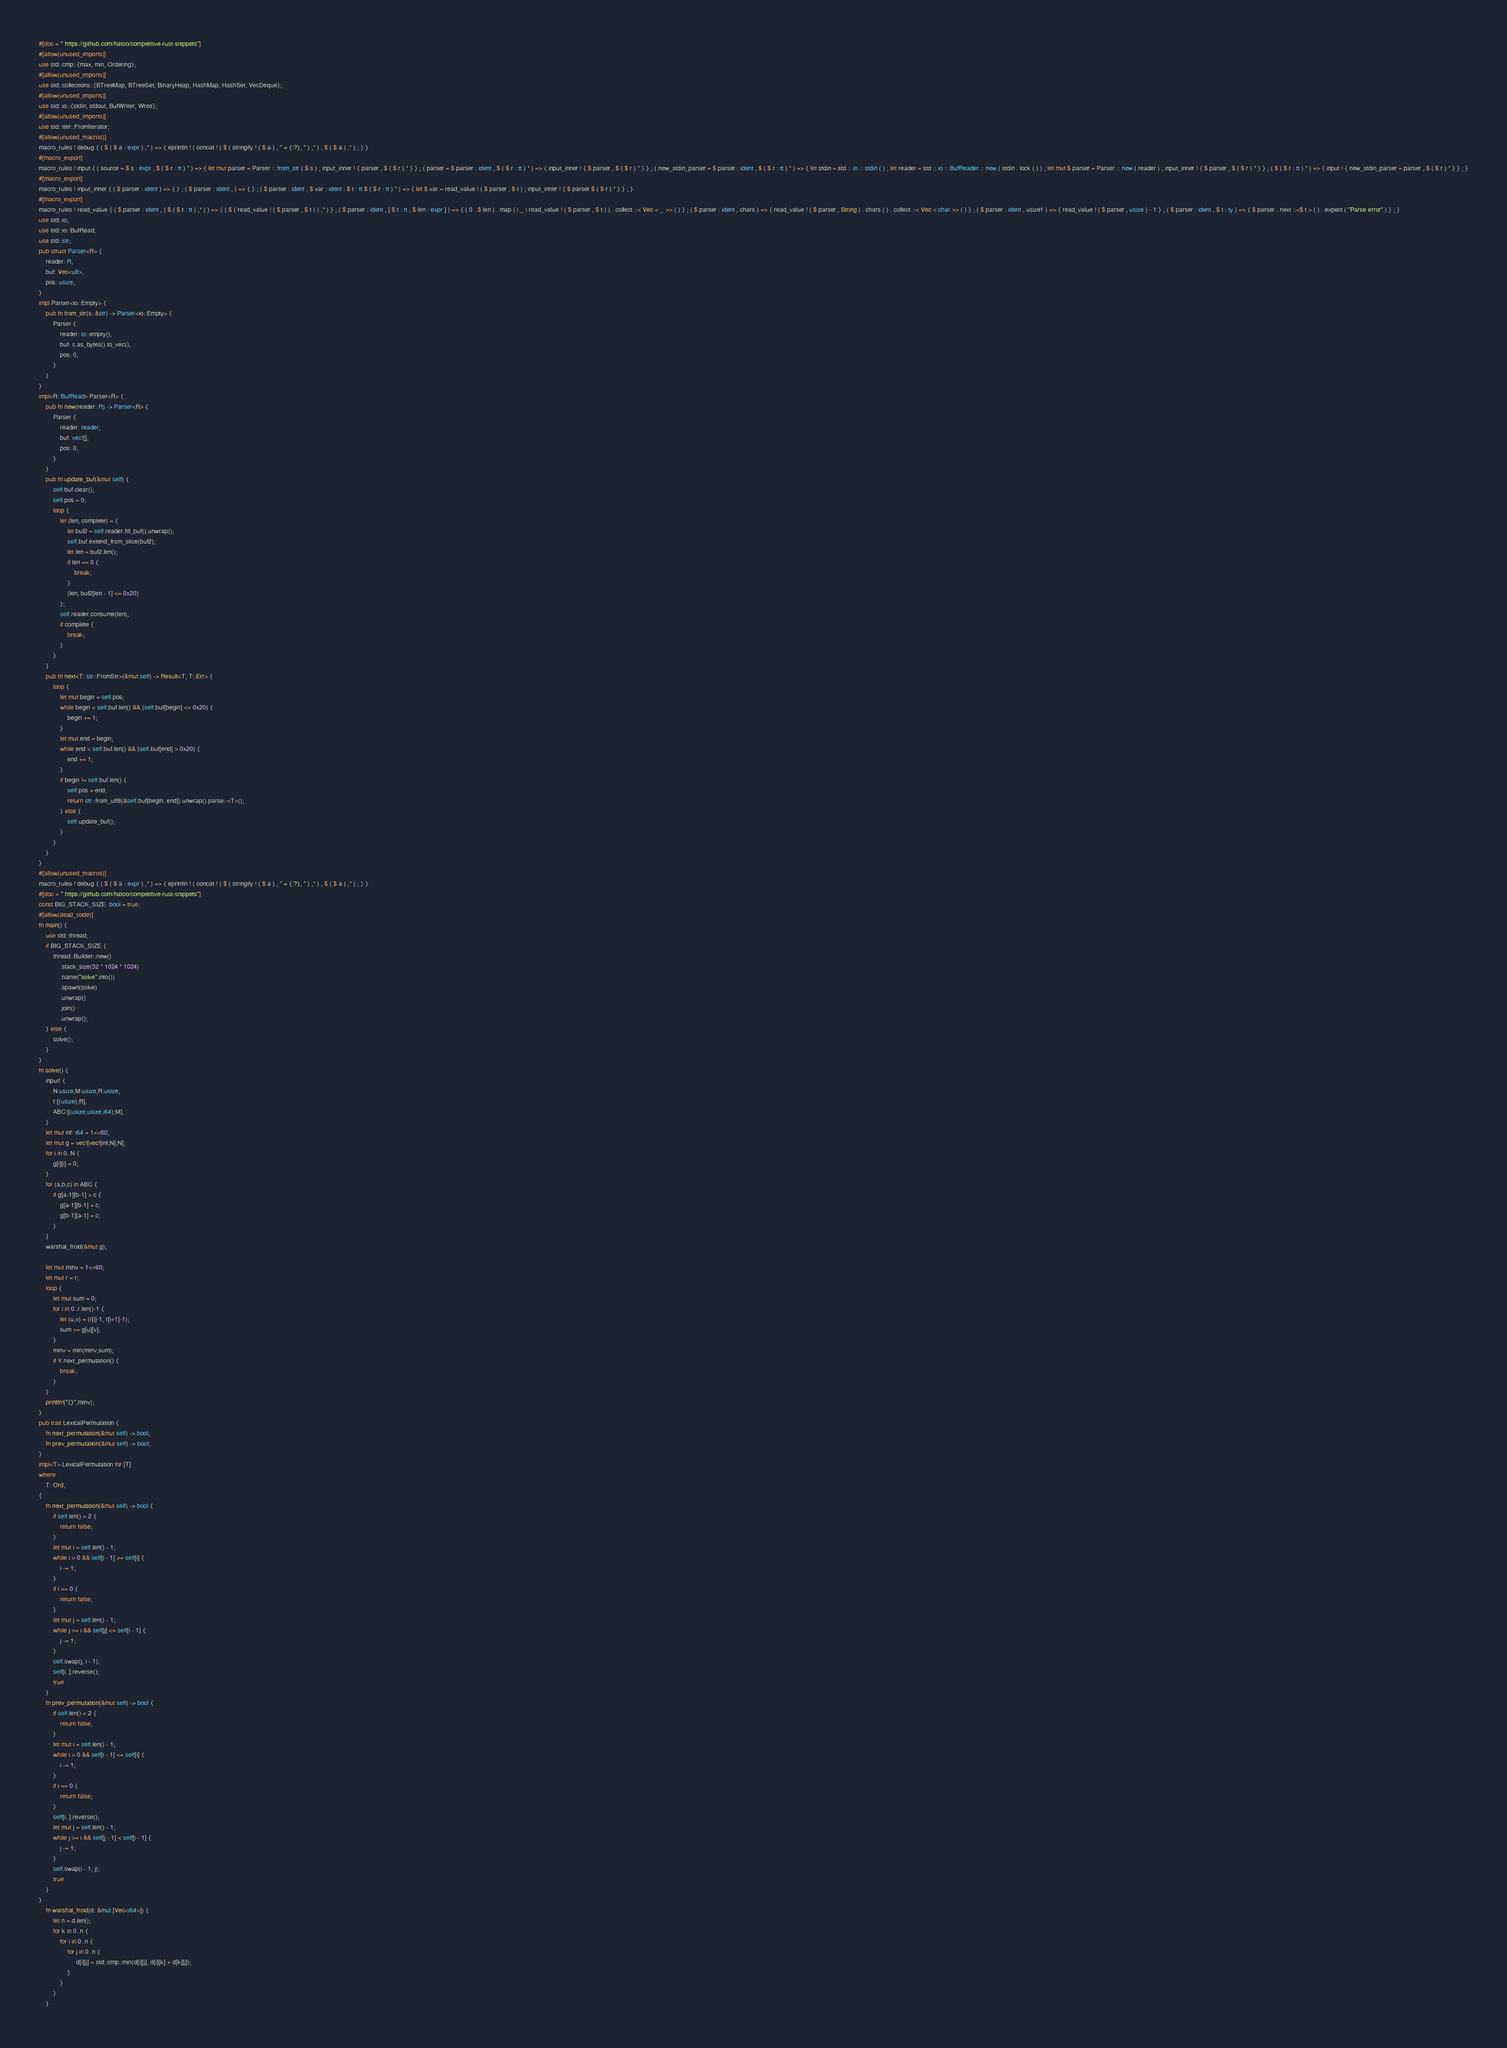Convert code to text. <code><loc_0><loc_0><loc_500><loc_500><_Rust_>#[doc = " https://github.com/hatoo/competitive-rust-snippets"]
#[allow(unused_imports)]
use std::cmp::{max, min, Ordering};
#[allow(unused_imports)]
use std::collections::{BTreeMap, BTreeSet, BinaryHeap, HashMap, HashSet, VecDeque};
#[allow(unused_imports)]
use std::io::{stdin, stdout, BufWriter, Write};
#[allow(unused_imports)]
use std::iter::FromIterator;
#[allow(unused_macros)]
macro_rules ! debug { ( $ ( $ a : expr ) ,* ) => { eprintln ! ( concat ! ( $ ( stringify ! ( $ a ) , " = {:?}, " ) ,* ) , $ ( $ a ) ,* ) ; } }
#[macro_export]
macro_rules ! input { ( source = $ s : expr , $ ( $ r : tt ) * ) => { let mut parser = Parser :: from_str ( $ s ) ; input_inner ! { parser , $ ( $ r ) * } } ; ( parser = $ parser : ident , $ ( $ r : tt ) * ) => { input_inner ! { $ parser , $ ( $ r ) * } } ; ( new_stdin_parser = $ parser : ident , $ ( $ r : tt ) * ) => { let stdin = std :: io :: stdin ( ) ; let reader = std :: io :: BufReader :: new ( stdin . lock ( ) ) ; let mut $ parser = Parser :: new ( reader ) ; input_inner ! { $ parser , $ ( $ r ) * } } ; ( $ ( $ r : tt ) * ) => { input ! { new_stdin_parser = parser , $ ( $ r ) * } } ; }
#[macro_export]
macro_rules ! input_inner { ( $ parser : ident ) => { } ; ( $ parser : ident , ) => { } ; ( $ parser : ident , $ var : ident : $ t : tt $ ( $ r : tt ) * ) => { let $ var = read_value ! ( $ parser , $ t ) ; input_inner ! { $ parser $ ( $ r ) * } } ; }
#[macro_export]
macro_rules ! read_value { ( $ parser : ident , ( $ ( $ t : tt ) ,* ) ) => { ( $ ( read_value ! ( $ parser , $ t ) ) ,* ) } ; ( $ parser : ident , [ $ t : tt ; $ len : expr ] ) => { ( 0 ..$ len ) . map ( | _ | read_value ! ( $ parser , $ t ) ) . collect ::< Vec < _ >> ( ) } ; ( $ parser : ident , chars ) => { read_value ! ( $ parser , String ) . chars ( ) . collect ::< Vec < char >> ( ) } ; ( $ parser : ident , usize1 ) => { read_value ! ( $ parser , usize ) - 1 } ; ( $ parser : ident , $ t : ty ) => { $ parser . next ::<$ t > ( ) . expect ( "Parse error" ) } ; }
use std::io;
use std::io::BufRead;
use std::str;
pub struct Parser<R> {
    reader: R,
    buf: Vec<u8>,
    pos: usize,
}
impl Parser<io::Empty> {
    pub fn from_str(s: &str) -> Parser<io::Empty> {
        Parser {
            reader: io::empty(),
            buf: s.as_bytes().to_vec(),
            pos: 0,
        }
    }
}
impl<R: BufRead> Parser<R> {
    pub fn new(reader: R) -> Parser<R> {
        Parser {
            reader: reader,
            buf: vec![],
            pos: 0,
        }
    }
    pub fn update_buf(&mut self) {
        self.buf.clear();
        self.pos = 0;
        loop {
            let (len, complete) = {
                let buf2 = self.reader.fill_buf().unwrap();
                self.buf.extend_from_slice(buf2);
                let len = buf2.len();
                if len == 0 {
                    break;
                }
                (len, buf2[len - 1] <= 0x20)
            };
            self.reader.consume(len);
            if complete {
                break;
            }
        }
    }
    pub fn next<T: str::FromStr>(&mut self) -> Result<T, T::Err> {
        loop {
            let mut begin = self.pos;
            while begin < self.buf.len() && (self.buf[begin] <= 0x20) {
                begin += 1;
            }
            let mut end = begin;
            while end < self.buf.len() && (self.buf[end] > 0x20) {
                end += 1;
            }
            if begin != self.buf.len() {
                self.pos = end;
                return str::from_utf8(&self.buf[begin..end]).unwrap().parse::<T>();
            } else {
                self.update_buf();
            }
        }
    }
}
#[allow(unused_macros)]
macro_rules ! debug { ( $ ( $ a : expr ) ,* ) => { eprintln ! ( concat ! ( $ ( stringify ! ( $ a ) , " = {:?}, " ) ,* ) , $ ( $ a ) ,* ) ; } }
#[doc = " https://github.com/hatoo/competitive-rust-snippets"]
const BIG_STACK_SIZE: bool = true;
#[allow(dead_code)]
fn main() {
    use std::thread;
    if BIG_STACK_SIZE {
        thread::Builder::new()
            .stack_size(32 * 1024 * 1024)
            .name("solve".into())
            .spawn(solve)
            .unwrap()
            .join()
            .unwrap();
    } else {
        solve();
    }
}
fn solve() {
    input! {
        N:usize,M:usize,R:usize,
        r:[(usize);R],
        ABC:[(usize,usize,i64);M],
    }
    let mut inf: i64 = 1<<60;
    let mut g = vec![vec![inf;N];N];
    for i in 0..N {
        g[i][i] = 0;
    }
    for (a,b,c) in ABC {
        if g[a-1][b-1] > c {
            g[a-1][b-1] = c;
            g[b-1][a-1] = c;
        }
    }
    warshal_froid(&mut g);

    let mut minv = 1<<60;
    let mut r = r;
    loop {
        let mut sum = 0;
        for i in 0..r.len()-1 {
            let (u,v) = (r[i]-1, r[i+1]-1);
            sum += g[u][v];
        }
        minv = min(minv,sum);
        if !r.next_permutation() {
            break;
        }
    }
    println!("{}",minv);
}
pub trait LexicalPermutation {
    fn next_permutation(&mut self) -> bool;
    fn prev_permutation(&mut self) -> bool;
}
impl<T> LexicalPermutation for [T]
where
    T: Ord,
{
    fn next_permutation(&mut self) -> bool {
        if self.len() < 2 {
            return false;
        }
        let mut i = self.len() - 1;
        while i > 0 && self[i - 1] >= self[i] {
            i -= 1;
        }
        if i == 0 {
            return false;
        }
        let mut j = self.len() - 1;
        while j >= i && self[j] <= self[i - 1] {
            j -= 1;
        }
        self.swap(j, i - 1);
        self[i..].reverse();
        true
    }
    fn prev_permutation(&mut self) -> bool {
        if self.len() < 2 {
            return false;
        }
        let mut i = self.len() - 1;
        while i > 0 && self[i - 1] <= self[i] {
            i -= 1;
        }
        if i == 0 {
            return false;
        }
        self[i..].reverse();
        let mut j = self.len() - 1;
        while j >= i && self[j - 1] < self[i - 1] {
            j -= 1;
        }
        self.swap(i - 1, j);
        true
    }
}
    fn warshal_froid(d: &mut [Vec<i64>]) {
        let n = d.len();
        for k in 0..n {
            for i in 0..n {
                for j in 0..n {
                     d[i][j] = std::cmp::min(d[i][j], d[i][k] + d[k][j]);
                }
            }
        }
    }</code> 